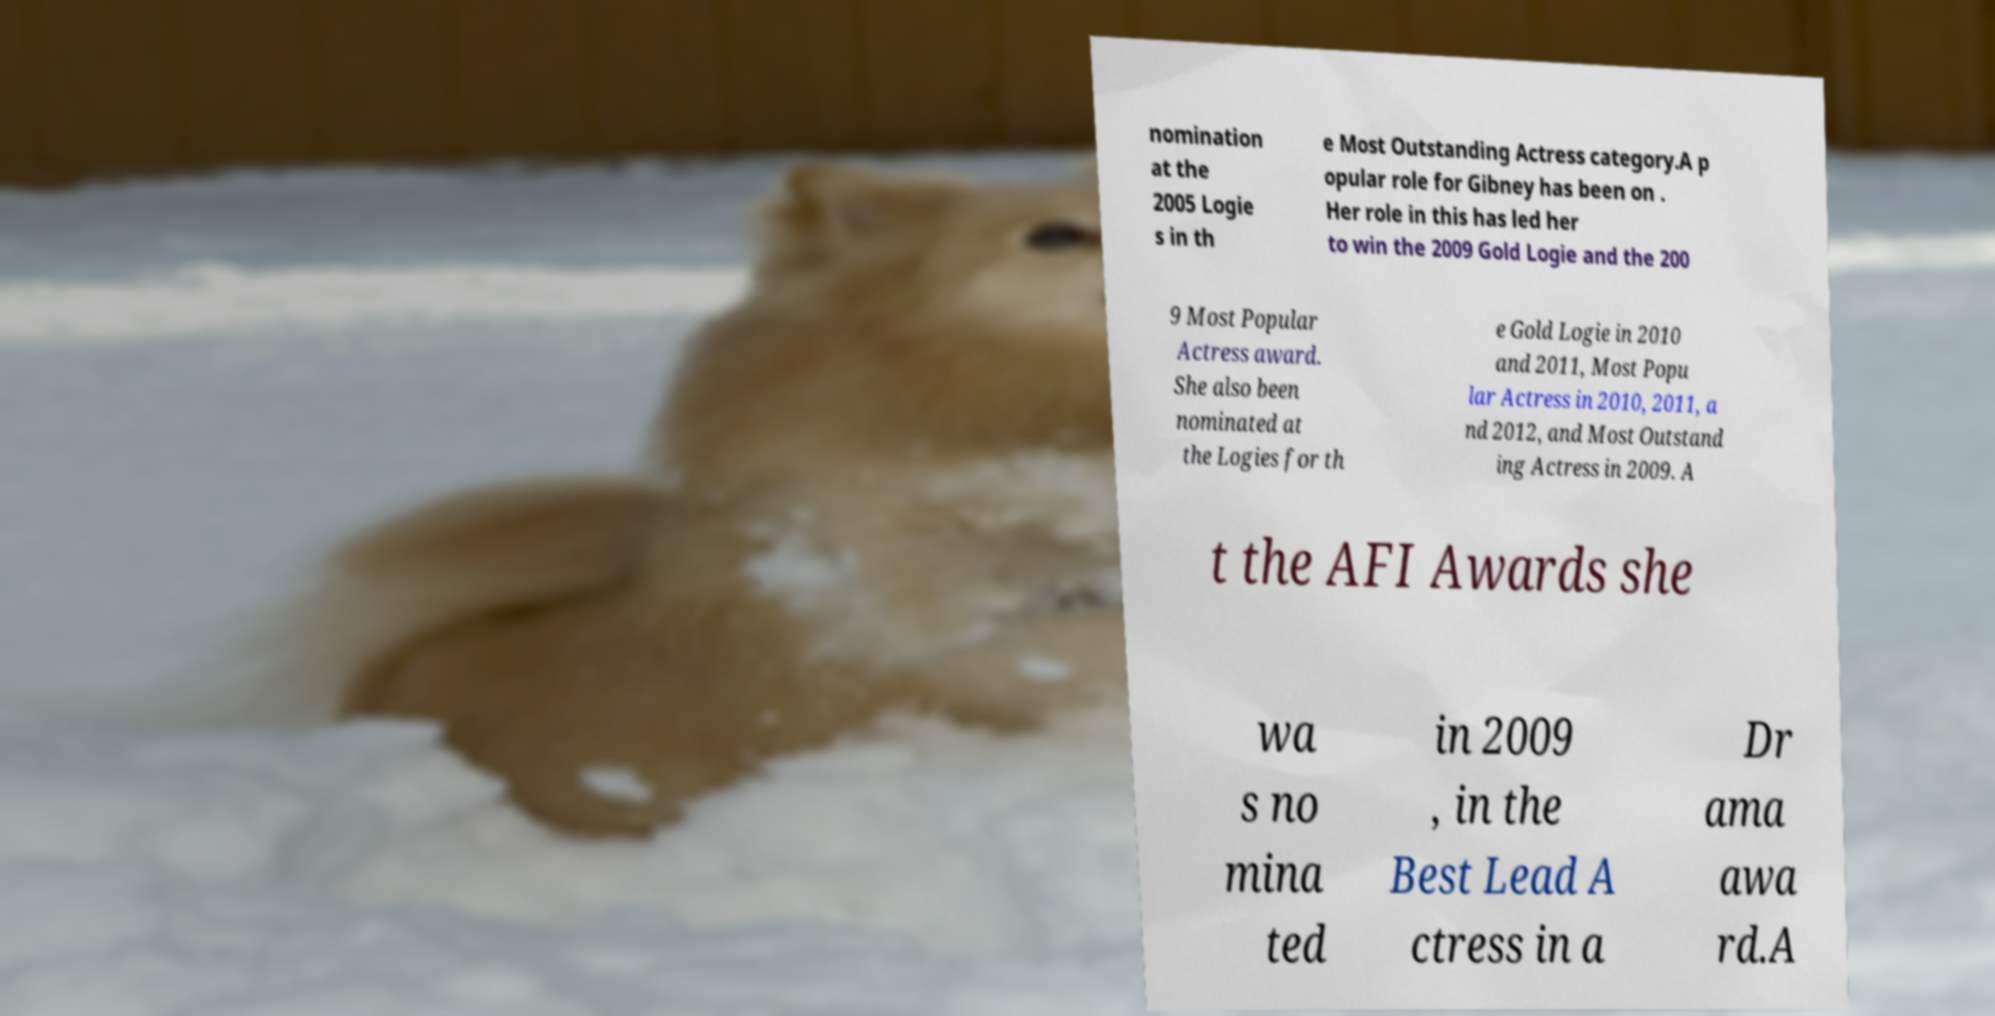I need the written content from this picture converted into text. Can you do that? nomination at the 2005 Logie s in th e Most Outstanding Actress category.A p opular role for Gibney has been on . Her role in this has led her to win the 2009 Gold Logie and the 200 9 Most Popular Actress award. She also been nominated at the Logies for th e Gold Logie in 2010 and 2011, Most Popu lar Actress in 2010, 2011, a nd 2012, and Most Outstand ing Actress in 2009. A t the AFI Awards she wa s no mina ted in 2009 , in the Best Lead A ctress in a Dr ama awa rd.A 